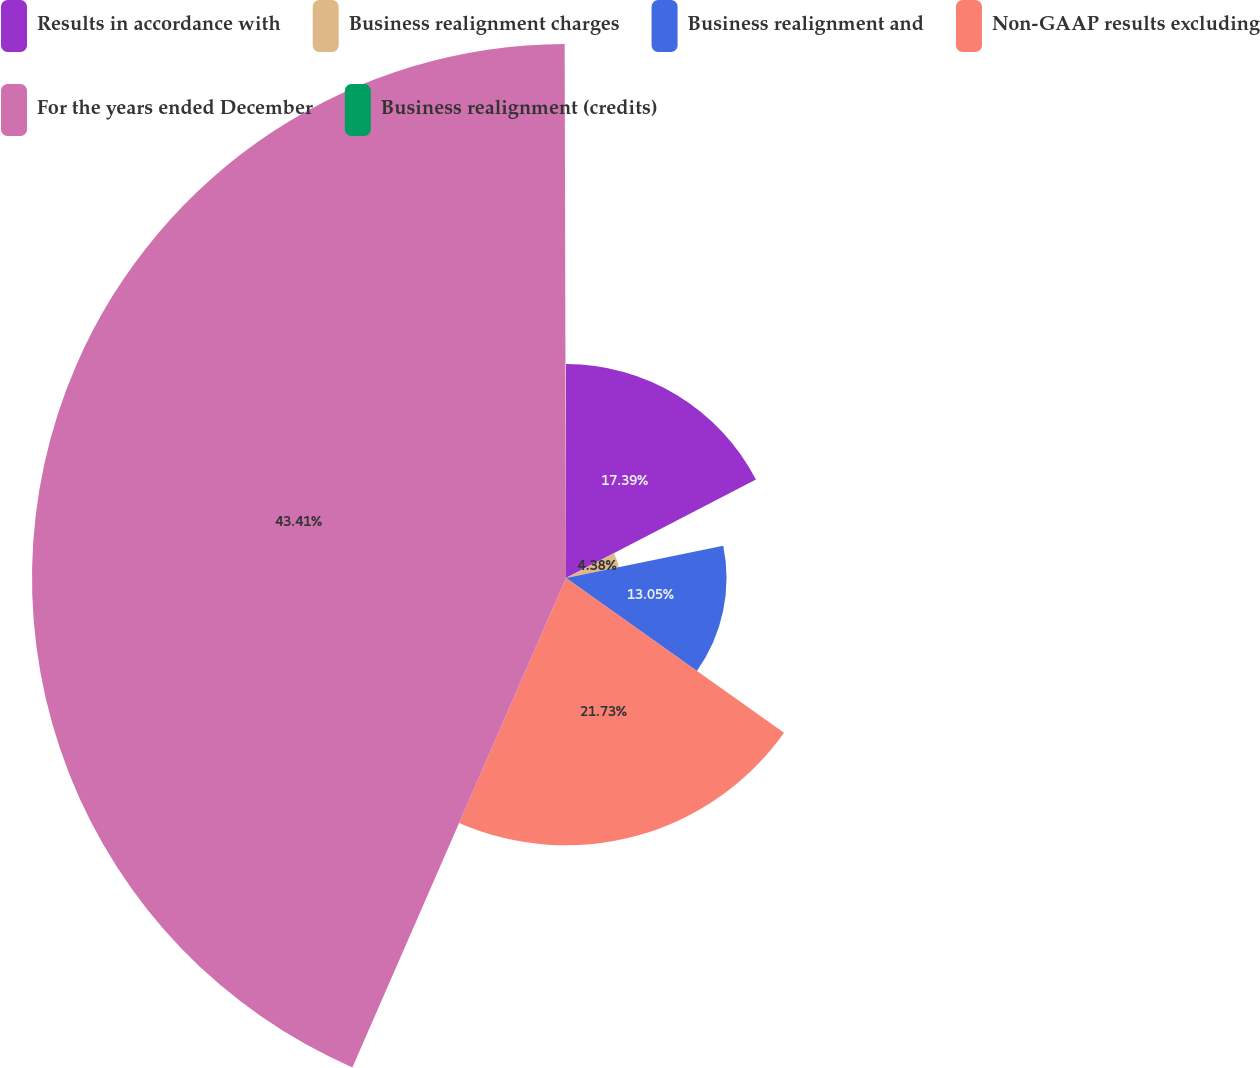Convert chart. <chart><loc_0><loc_0><loc_500><loc_500><pie_chart><fcel>Results in accordance with<fcel>Business realignment charges<fcel>Business realignment and<fcel>Non-GAAP results excluding<fcel>For the years ended December<fcel>Business realignment (credits)<nl><fcel>17.39%<fcel>4.38%<fcel>13.05%<fcel>21.73%<fcel>43.41%<fcel>0.04%<nl></chart> 